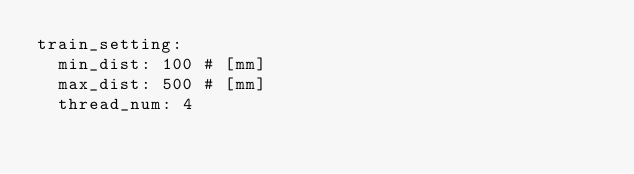<code> <loc_0><loc_0><loc_500><loc_500><_YAML_>train_setting:
  min_dist: 100 # [mm]
  max_dist: 500 # [mm]
  thread_num: 4
</code> 